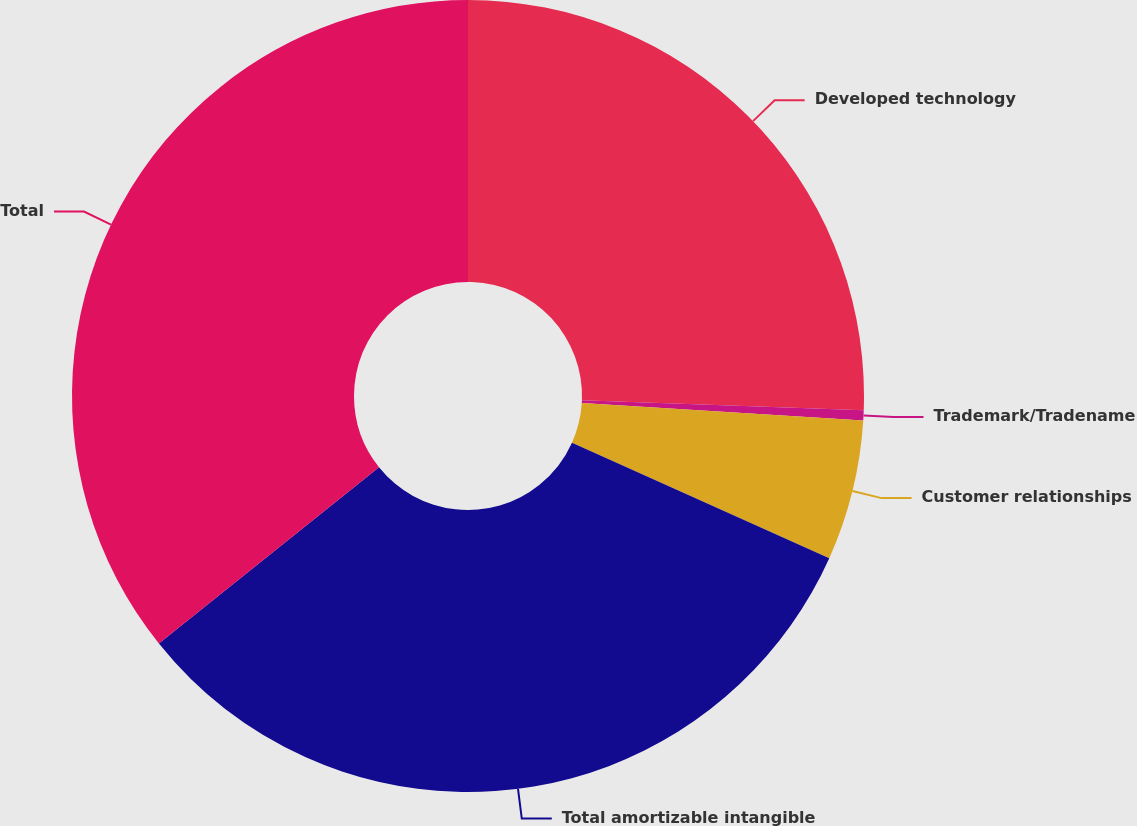Convert chart. <chart><loc_0><loc_0><loc_500><loc_500><pie_chart><fcel>Developed technology<fcel>Trademark/Tradename<fcel>Customer relationships<fcel>Total amortizable intangible<fcel>Total<nl><fcel>25.58%<fcel>0.41%<fcel>5.73%<fcel>32.54%<fcel>35.75%<nl></chart> 